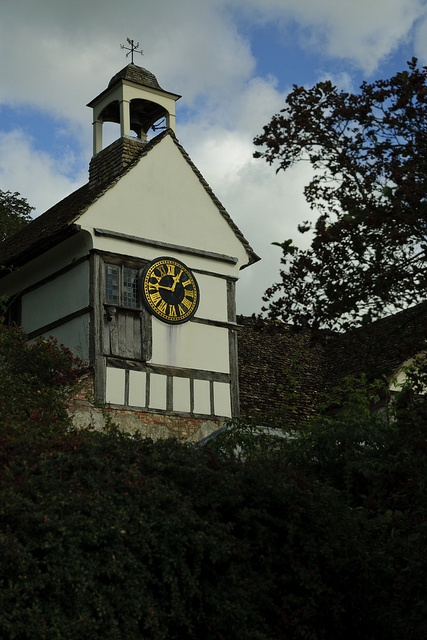Describe the objects in this image and their specific colors. I can see a clock in gray, black, and olive tones in this image. 